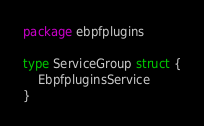<code> <loc_0><loc_0><loc_500><loc_500><_Go_>package ebpfplugins

type ServiceGroup struct {
	EbpfpluginsService
}
</code> 